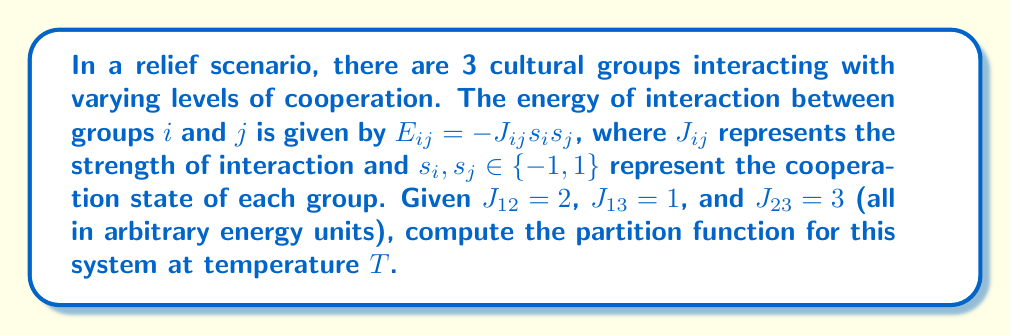Could you help me with this problem? To compute the partition function, we follow these steps:

1) The partition function is given by:
   $$Z = \sum_{\text{all states}} e^{-\beta E}$$
   where $\beta = \frac{1}{k_B T}$, $k_B$ is Boltzmann's constant, and T is temperature.

2) In this system, we have 3 groups, each with 2 possible states. So there are $2^3 = 8$ total states.

3) The total energy for a state is:
   $$E = -J_{12}s_1s_2 - J_{13}s_1s_3 - J_{23}s_2s_3$$

4) Let's calculate the energy for each state:
   $(s_1, s_2, s_3)$: Energy
   $(1, 1, 1)$: $E = -2 - 1 - 3 = -6$
   $(1, 1, -1)$: $E = -2 + 1 + 3 = 2$
   $(1, -1, 1)$: $E = 2 - 1 + 3 = 4$
   $(1, -1, -1)$: $E = 2 + 1 - 3 = 0$
   $(-1, 1, 1)$: $E = 2 + 1 + 3 = 6$
   $(-1, 1, -1)$: $E = 2 - 1 - 3 = -2$
   $(-1, -1, 1)$: $E = -2 + 1 - 3 = -4$
   $(-1, -1, -1)$: $E = -2 - 1 + 3 = 0$

5) Now we can write out the partition function:
   $$Z = e^{6\beta} + e^{-2\beta} + e^{4\beta} + 2 + e^{-6\beta} + e^{2\beta} + e^{-4\beta}$$

6) This can be simplified to:
   $$Z = e^{6\beta} + e^{4\beta} + e^{2\beta} + 2 + e^{-2\beta} + e^{-4\beta} + e^{-6\beta}$$
Answer: $Z = e^{6\beta} + e^{4\beta} + e^{2\beta} + 2 + e^{-2\beta} + e^{-4\beta} + e^{-6\beta}$ 